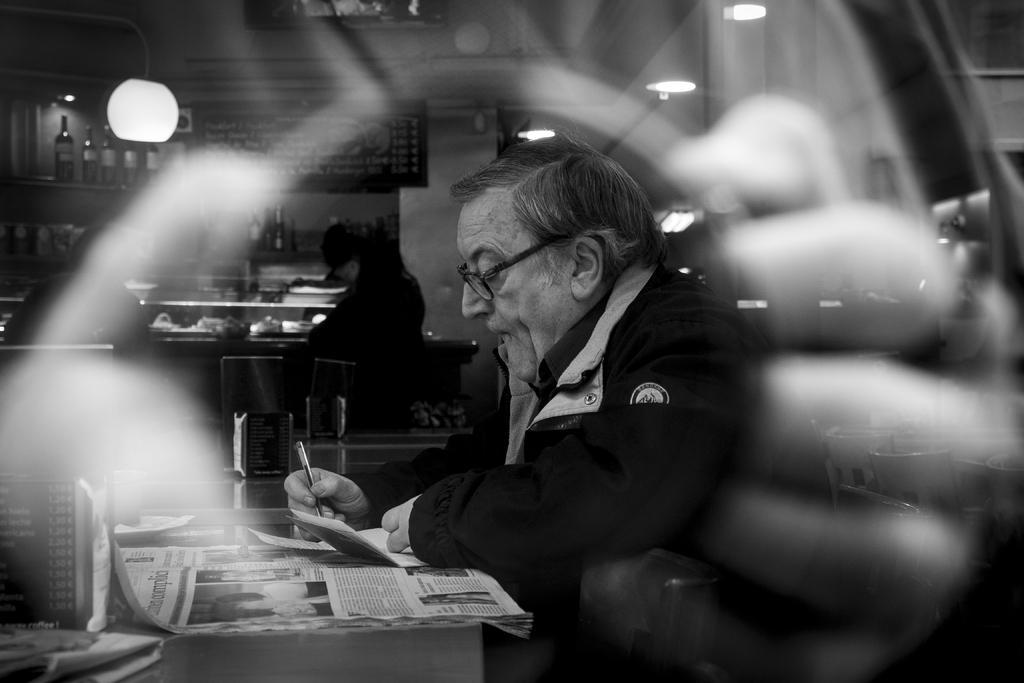Can you describe this image briefly? As we can see there is a black image and its a cafeteria in which a man sitting and he writing something with pen on a paper and there is a newspaper on the table and along with it there is a menu card and at the back there is a open kitchen where the food items are served. There is a person sitting on the chair and behind it there is a board on which menu is written beside it there are wine bottle kept in a rack. 